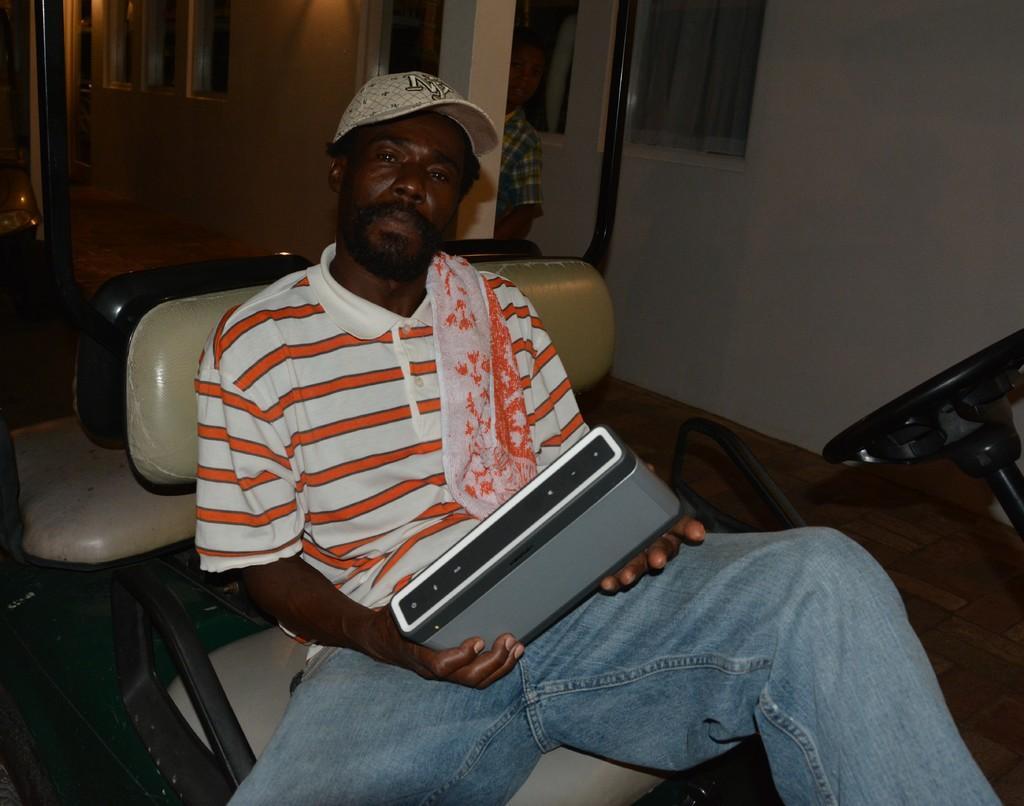Please provide a concise description of this image. In this image we can see a person wearing cap is holding something in the hand. He is sitting on a seat. In the back there is a person. Also there are walls with windows. On the right side we can see a steering. 